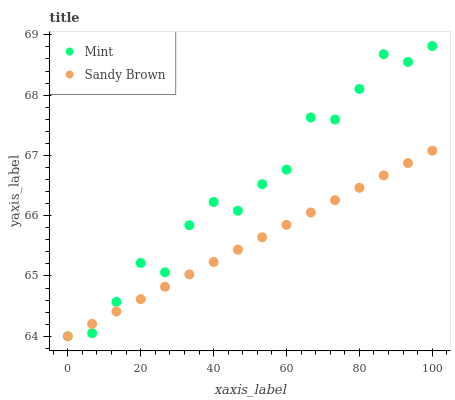Does Sandy Brown have the minimum area under the curve?
Answer yes or no. Yes. Does Mint have the maximum area under the curve?
Answer yes or no. Yes. Does Mint have the minimum area under the curve?
Answer yes or no. No. Is Sandy Brown the smoothest?
Answer yes or no. Yes. Is Mint the roughest?
Answer yes or no. Yes. Is Mint the smoothest?
Answer yes or no. No. Does Sandy Brown have the lowest value?
Answer yes or no. Yes. Does Mint have the highest value?
Answer yes or no. Yes. Does Sandy Brown intersect Mint?
Answer yes or no. Yes. Is Sandy Brown less than Mint?
Answer yes or no. No. Is Sandy Brown greater than Mint?
Answer yes or no. No. 